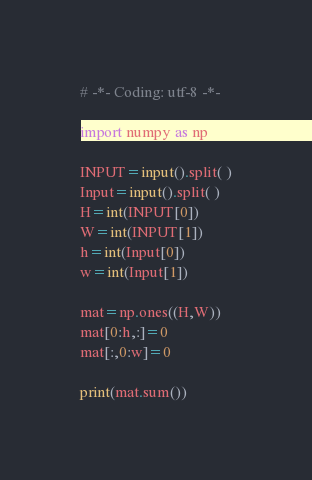<code> <loc_0><loc_0><loc_500><loc_500><_Python_># -*- Coding: utf-8 -*-

import numpy as np

INPUT=input().split( )
Input=input().split( )
H=int(INPUT[0])
W=int(INPUT[1])
h=int(Input[0])
w=int(Input[1])

mat=np.ones((H,W))
mat[0:h,:]=0
mat[:,0:w]=0

print(mat.sum())</code> 